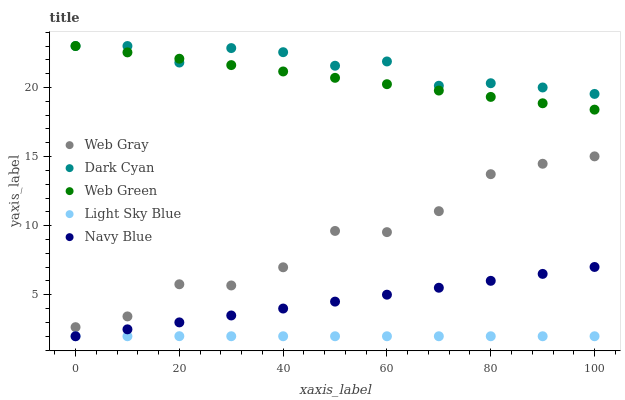Does Light Sky Blue have the minimum area under the curve?
Answer yes or no. Yes. Does Dark Cyan have the maximum area under the curve?
Answer yes or no. Yes. Does Navy Blue have the minimum area under the curve?
Answer yes or no. No. Does Navy Blue have the maximum area under the curve?
Answer yes or no. No. Is Navy Blue the smoothest?
Answer yes or no. Yes. Is Web Gray the roughest?
Answer yes or no. Yes. Is Web Gray the smoothest?
Answer yes or no. No. Is Navy Blue the roughest?
Answer yes or no. No. Does Navy Blue have the lowest value?
Answer yes or no. Yes. Does Web Gray have the lowest value?
Answer yes or no. No. Does Web Green have the highest value?
Answer yes or no. Yes. Does Navy Blue have the highest value?
Answer yes or no. No. Is Light Sky Blue less than Web Gray?
Answer yes or no. Yes. Is Dark Cyan greater than Light Sky Blue?
Answer yes or no. Yes. Does Light Sky Blue intersect Navy Blue?
Answer yes or no. Yes. Is Light Sky Blue less than Navy Blue?
Answer yes or no. No. Is Light Sky Blue greater than Navy Blue?
Answer yes or no. No. Does Light Sky Blue intersect Web Gray?
Answer yes or no. No. 